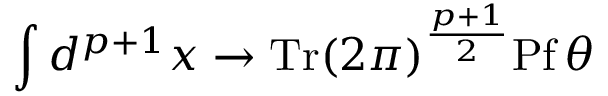Convert formula to latex. <formula><loc_0><loc_0><loc_500><loc_500>\int d ^ { p + 1 } x \rightarrow T r ( 2 \pi ) ^ { \frac { p + 1 } { 2 } } P f \, \theta</formula> 